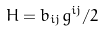Convert formula to latex. <formula><loc_0><loc_0><loc_500><loc_500>H = b _ { i j } g ^ { i j } / 2</formula> 